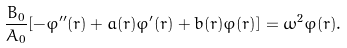<formula> <loc_0><loc_0><loc_500><loc_500>\frac { B _ { 0 } } { A _ { 0 } } [ - \varphi ^ { \prime \prime } ( r ) + a ( r ) \varphi ^ { \prime } ( r ) + b ( r ) \varphi ( r ) ] = \omega ^ { 2 } \varphi ( r ) .</formula> 